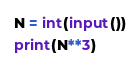Convert code to text. <code><loc_0><loc_0><loc_500><loc_500><_Python_>N = int(input())
print(N**3)</code> 